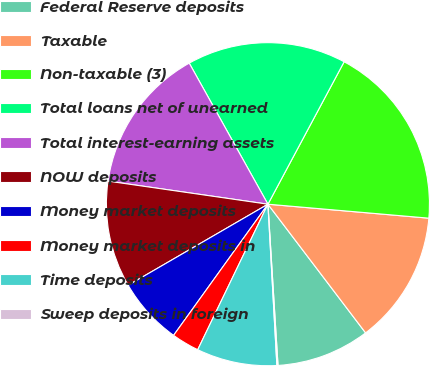Convert chart. <chart><loc_0><loc_0><loc_500><loc_500><pie_chart><fcel>Federal Reserve deposits<fcel>Taxable<fcel>Non-taxable (3)<fcel>Total loans net of unearned<fcel>Total interest-earning assets<fcel>NOW deposits<fcel>Money market deposits<fcel>Money market deposits in<fcel>Time deposits<fcel>Sweep deposits in foreign<nl><fcel>9.34%<fcel>13.29%<fcel>18.56%<fcel>15.92%<fcel>14.62%<fcel>10.65%<fcel>6.71%<fcel>2.77%<fcel>8.04%<fcel>0.11%<nl></chart> 